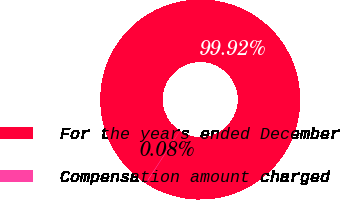Convert chart to OTSL. <chart><loc_0><loc_0><loc_500><loc_500><pie_chart><fcel>For the years ended December<fcel>Compensation amount charged<nl><fcel>99.92%<fcel>0.08%<nl></chart> 